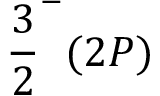Convert formula to latex. <formula><loc_0><loc_0><loc_500><loc_500>\frac { 3 } { 2 } ^ { - } ( 2 P )</formula> 